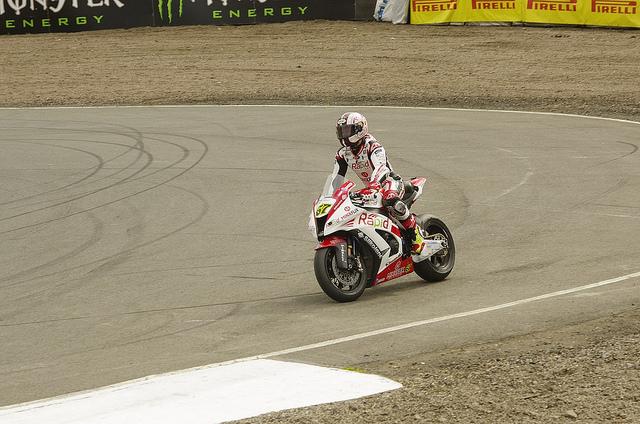How many motorcycles pictured?
Keep it brief. 1. What color is the motorcycle?
Answer briefly. Red and white. What is the name of one of the track sponsors?
Quick response, please. Monster. Is the bike being ridden on dirt or asphalt?
Keep it brief. Asphalt. How many bikes are seen?
Answer briefly. 1. Is that bike seat soft?
Be succinct. No. What does the yellow sign say?
Keep it brief. Pirelli. How many times does "energy" appear in the picture?
Quick response, please. 2. What surface are they pushing the motorcycle on?
Short answer required. Asphalt. What is the number on the front of this motorcycle?
Write a very short answer. 67. Who is sponsoring this event?
Be succinct. Monster. 